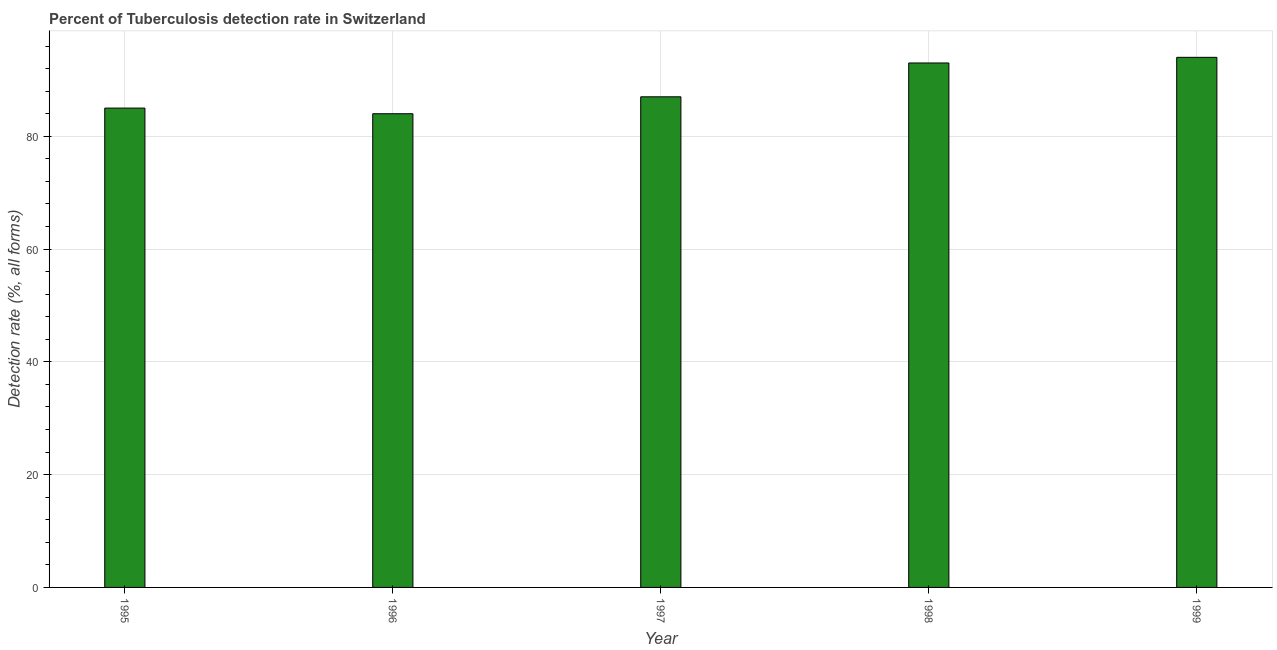Does the graph contain any zero values?
Keep it short and to the point. No. What is the title of the graph?
Make the answer very short. Percent of Tuberculosis detection rate in Switzerland. What is the label or title of the X-axis?
Provide a short and direct response. Year. What is the label or title of the Y-axis?
Give a very brief answer. Detection rate (%, all forms). What is the detection rate of tuberculosis in 1998?
Ensure brevity in your answer.  93. Across all years, what is the maximum detection rate of tuberculosis?
Provide a succinct answer. 94. Across all years, what is the minimum detection rate of tuberculosis?
Ensure brevity in your answer.  84. In which year was the detection rate of tuberculosis maximum?
Provide a short and direct response. 1999. What is the sum of the detection rate of tuberculosis?
Offer a very short reply. 443. What is the median detection rate of tuberculosis?
Offer a very short reply. 87. In how many years, is the detection rate of tuberculosis greater than 56 %?
Your answer should be compact. 5. Do a majority of the years between 1998 and 1996 (inclusive) have detection rate of tuberculosis greater than 40 %?
Provide a short and direct response. Yes. What is the ratio of the detection rate of tuberculosis in 1995 to that in 1996?
Provide a short and direct response. 1.01. Is the difference between the detection rate of tuberculosis in 1995 and 1999 greater than the difference between any two years?
Provide a succinct answer. No. What is the difference between the highest and the second highest detection rate of tuberculosis?
Provide a short and direct response. 1. In how many years, is the detection rate of tuberculosis greater than the average detection rate of tuberculosis taken over all years?
Make the answer very short. 2. Are all the bars in the graph horizontal?
Your answer should be compact. No. What is the Detection rate (%, all forms) in 1998?
Offer a very short reply. 93. What is the Detection rate (%, all forms) in 1999?
Keep it short and to the point. 94. What is the difference between the Detection rate (%, all forms) in 1995 and 1996?
Provide a succinct answer. 1. What is the difference between the Detection rate (%, all forms) in 1995 and 1999?
Keep it short and to the point. -9. What is the difference between the Detection rate (%, all forms) in 1996 and 1998?
Your answer should be compact. -9. What is the ratio of the Detection rate (%, all forms) in 1995 to that in 1996?
Ensure brevity in your answer.  1.01. What is the ratio of the Detection rate (%, all forms) in 1995 to that in 1997?
Keep it short and to the point. 0.98. What is the ratio of the Detection rate (%, all forms) in 1995 to that in 1998?
Give a very brief answer. 0.91. What is the ratio of the Detection rate (%, all forms) in 1995 to that in 1999?
Your answer should be very brief. 0.9. What is the ratio of the Detection rate (%, all forms) in 1996 to that in 1997?
Give a very brief answer. 0.97. What is the ratio of the Detection rate (%, all forms) in 1996 to that in 1998?
Offer a very short reply. 0.9. What is the ratio of the Detection rate (%, all forms) in 1996 to that in 1999?
Your response must be concise. 0.89. What is the ratio of the Detection rate (%, all forms) in 1997 to that in 1998?
Your response must be concise. 0.94. What is the ratio of the Detection rate (%, all forms) in 1997 to that in 1999?
Your answer should be compact. 0.93. 